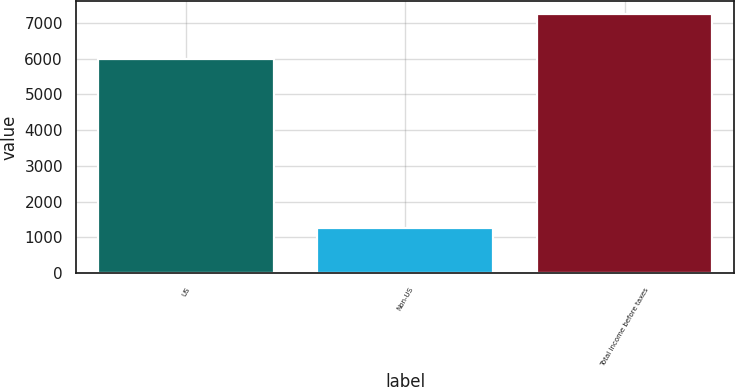Convert chart. <chart><loc_0><loc_0><loc_500><loc_500><bar_chart><fcel>US<fcel>Non-US<fcel>Total income before taxes<nl><fcel>5992<fcel>1265<fcel>7257<nl></chart> 